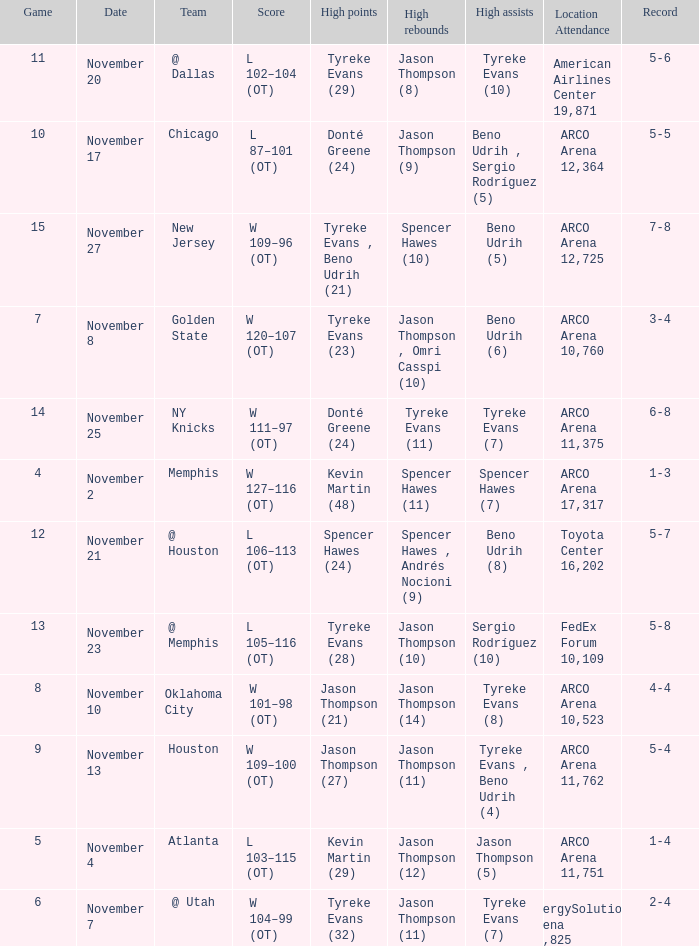Could you help me parse every detail presented in this table? {'header': ['Game', 'Date', 'Team', 'Score', 'High points', 'High rebounds', 'High assists', 'Location Attendance', 'Record'], 'rows': [['11', 'November 20', '@ Dallas', 'L 102–104 (OT)', 'Tyreke Evans (29)', 'Jason Thompson (8)', 'Tyreke Evans (10)', 'American Airlines Center 19,871', '5-6'], ['10', 'November 17', 'Chicago', 'L 87–101 (OT)', 'Donté Greene (24)', 'Jason Thompson (9)', 'Beno Udrih , Sergio Rodríguez (5)', 'ARCO Arena 12,364', '5-5'], ['15', 'November 27', 'New Jersey', 'W 109–96 (OT)', 'Tyreke Evans , Beno Udrih (21)', 'Spencer Hawes (10)', 'Beno Udrih (5)', 'ARCO Arena 12,725', '7-8'], ['7', 'November 8', 'Golden State', 'W 120–107 (OT)', 'Tyreke Evans (23)', 'Jason Thompson , Omri Casspi (10)', 'Beno Udrih (6)', 'ARCO Arena 10,760', '3-4'], ['14', 'November 25', 'NY Knicks', 'W 111–97 (OT)', 'Donté Greene (24)', 'Tyreke Evans (11)', 'Tyreke Evans (7)', 'ARCO Arena 11,375', '6-8'], ['4', 'November 2', 'Memphis', 'W 127–116 (OT)', 'Kevin Martin (48)', 'Spencer Hawes (11)', 'Spencer Hawes (7)', 'ARCO Arena 17,317', '1-3'], ['12', 'November 21', '@ Houston', 'L 106–113 (OT)', 'Spencer Hawes (24)', 'Spencer Hawes , Andrés Nocioni (9)', 'Beno Udrih (8)', 'Toyota Center 16,202', '5-7'], ['13', 'November 23', '@ Memphis', 'L 105–116 (OT)', 'Tyreke Evans (28)', 'Jason Thompson (10)', 'Sergio Rodríguez (10)', 'FedEx Forum 10,109', '5-8'], ['8', 'November 10', 'Oklahoma City', 'W 101–98 (OT)', 'Jason Thompson (21)', 'Jason Thompson (14)', 'Tyreke Evans (8)', 'ARCO Arena 10,523', '4-4'], ['9', 'November 13', 'Houston', 'W 109–100 (OT)', 'Jason Thompson (27)', 'Jason Thompson (11)', 'Tyreke Evans , Beno Udrih (4)', 'ARCO Arena 11,762', '5-4'], ['5', 'November 4', 'Atlanta', 'L 103–115 (OT)', 'Kevin Martin (29)', 'Jason Thompson (12)', 'Jason Thompson (5)', 'ARCO Arena 11,751', '1-4'], ['6', 'November 7', '@ Utah', 'W 104–99 (OT)', 'Tyreke Evans (32)', 'Jason Thompson (11)', 'Tyreke Evans (7)', 'EnergySolutions Arena 18,825', '2-4']]} If the record is 5-5, what is the game maximum? 10.0. 